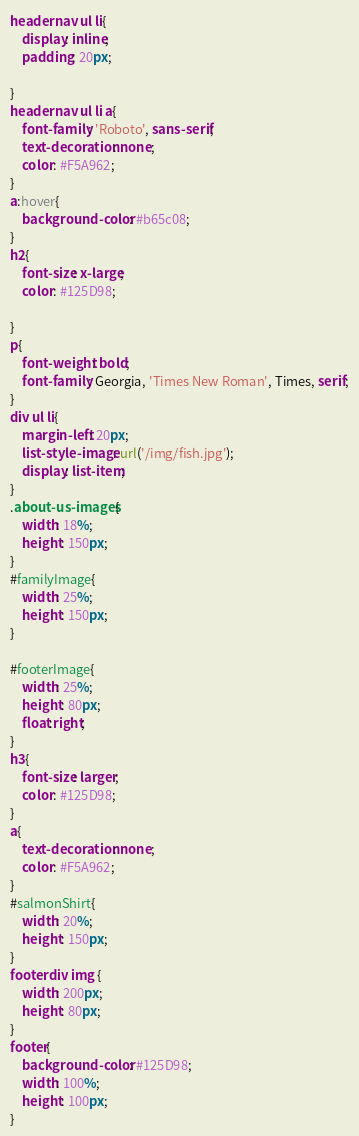<code> <loc_0><loc_0><loc_500><loc_500><_CSS_>header nav ul li{
    display: inline;
    padding: 20px;
    
}
header nav ul li a{
    font-family: 'Roboto', sans-serif;
    text-decoration: none;
    color: #F5A962;
}
a:hover{
    background-color: #b65c08;
}
h2{
    font-size: x-large;
    color: #125D98;
    
}
p{
    font-weight: bold;
    font-family: Georgia, 'Times New Roman', Times, serif;
}
div ul li{ 
    margin-left: 20px;
    list-style-image: url('/img/fish.jpg');
    display: list-item;
}
.about-us-images{
    width: 18%;
    height: 150px;
}
#familyImage{
    width: 25%;
    height: 150px;
}

#footerImage{
    width: 25%;
    height: 80px;
    float:right;
}
h3{
    font-size: larger;
    color: #125D98;
}
a{
    text-decoration: none;
    color: #F5A962;
}
#salmonShirt{
    width: 20%;
    height: 150px;
}
footer div img {
    width: 200px;
    height: 80px;
}
footer{
    background-color: #125D98;
    width: 100%;
    height: 100px;
}

</code> 